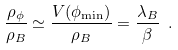Convert formula to latex. <formula><loc_0><loc_0><loc_500><loc_500>\frac { \rho _ { \phi } } { \rho _ { B } } \simeq \frac { V ( \phi _ { \min } ) } { \rho _ { B } } = \frac { \lambda _ { B } } { \beta } \ .</formula> 